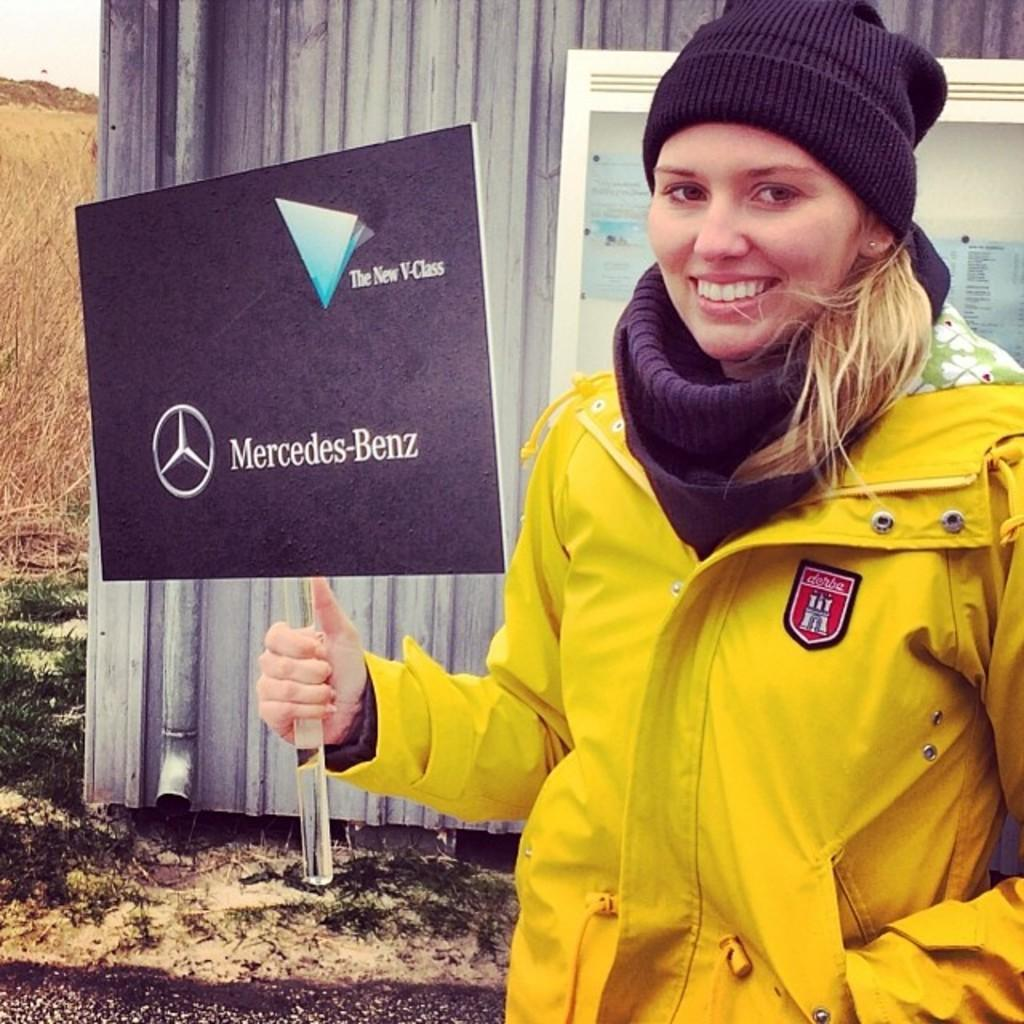What is the person in the image holding? The person is holding a board with images and text. What type of surface can be seen beneath the person's feet? There is grass visible in the image. What is on the wall in the image? There is a poster on the wall. What can be seen above the person in the image? The sky is visible in the image. How many women are visible in the image? There is no mention of women in the provided facts, so we cannot determine the number of women in the image. 